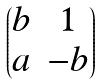Convert formula to latex. <formula><loc_0><loc_0><loc_500><loc_500>\begin{pmatrix} b & 1 \\ a & - b \end{pmatrix}</formula> 